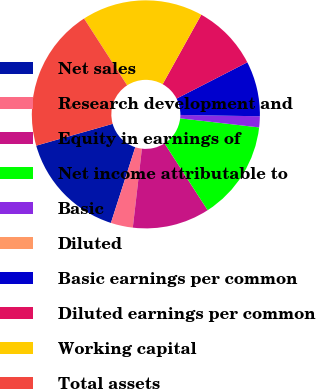Convert chart. <chart><loc_0><loc_0><loc_500><loc_500><pie_chart><fcel>Net sales<fcel>Research development and<fcel>Equity in earnings of<fcel>Net income attributable to<fcel>Basic<fcel>Diluted<fcel>Basic earnings per common<fcel>Diluted earnings per common<fcel>Working capital<fcel>Total assets<nl><fcel>15.62%<fcel>3.13%<fcel>10.94%<fcel>14.06%<fcel>1.56%<fcel>0.0%<fcel>7.81%<fcel>9.38%<fcel>17.19%<fcel>20.31%<nl></chart> 